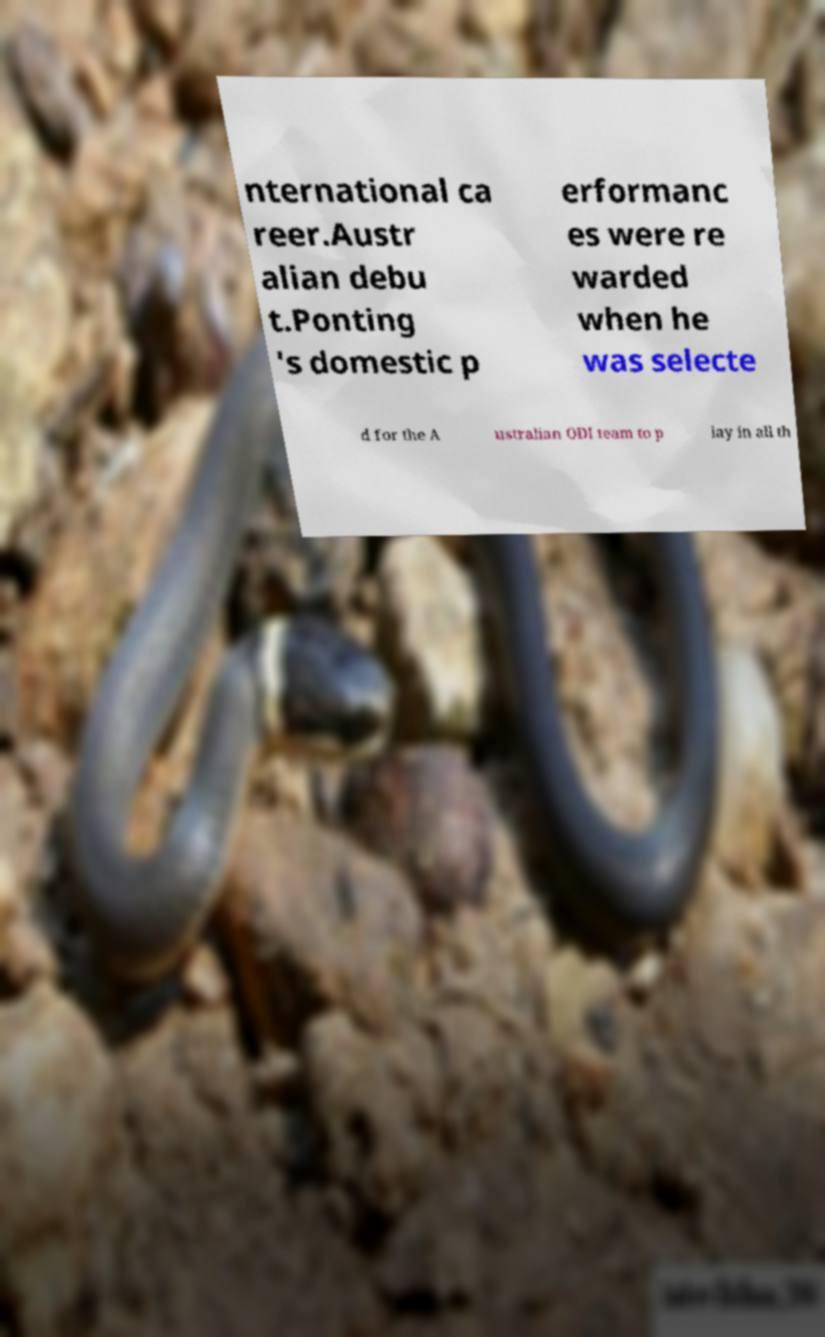What messages or text are displayed in this image? I need them in a readable, typed format. nternational ca reer.Austr alian debu t.Ponting 's domestic p erformanc es were re warded when he was selecte d for the A ustralian ODI team to p lay in all th 